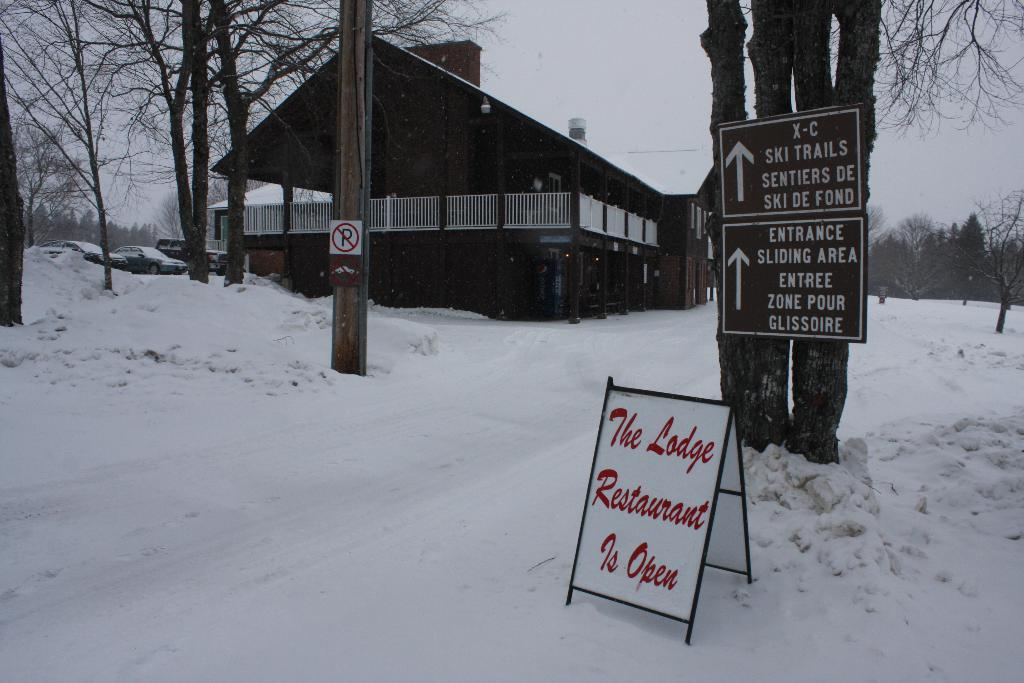What is the main object in the image? There is a board in the image. Are there any other signage-related objects in the image? Yes, there are sign boards in the image. What type of natural elements can be seen in the image? There are trees in the image. What structure is present in the image? There is a pole in the image. What can be seen in the background of the image? There is a building in the background of the image. What type of vehicles are visible in the image? There are cars on the left side of the image. What weather condition is depicted in the image? There is snow visible in the image. What type of wound can be seen on the board in the image? There is no wound present on the board in the image. What topic is being discussed on the board in the image? The board does not depict a discussion; it is a standalone object. What type of fruit is hanging from the trees in the image? There is no fruit, including bananas, visible on the trees in the image. 